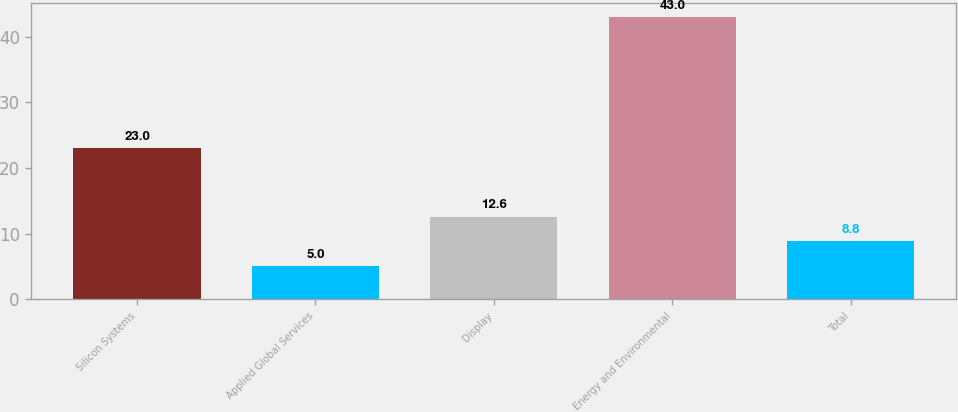Convert chart. <chart><loc_0><loc_0><loc_500><loc_500><bar_chart><fcel>Silicon Systems<fcel>Applied Global Services<fcel>Display<fcel>Energy and Environmental<fcel>Total<nl><fcel>23<fcel>5<fcel>12.6<fcel>43<fcel>8.8<nl></chart> 